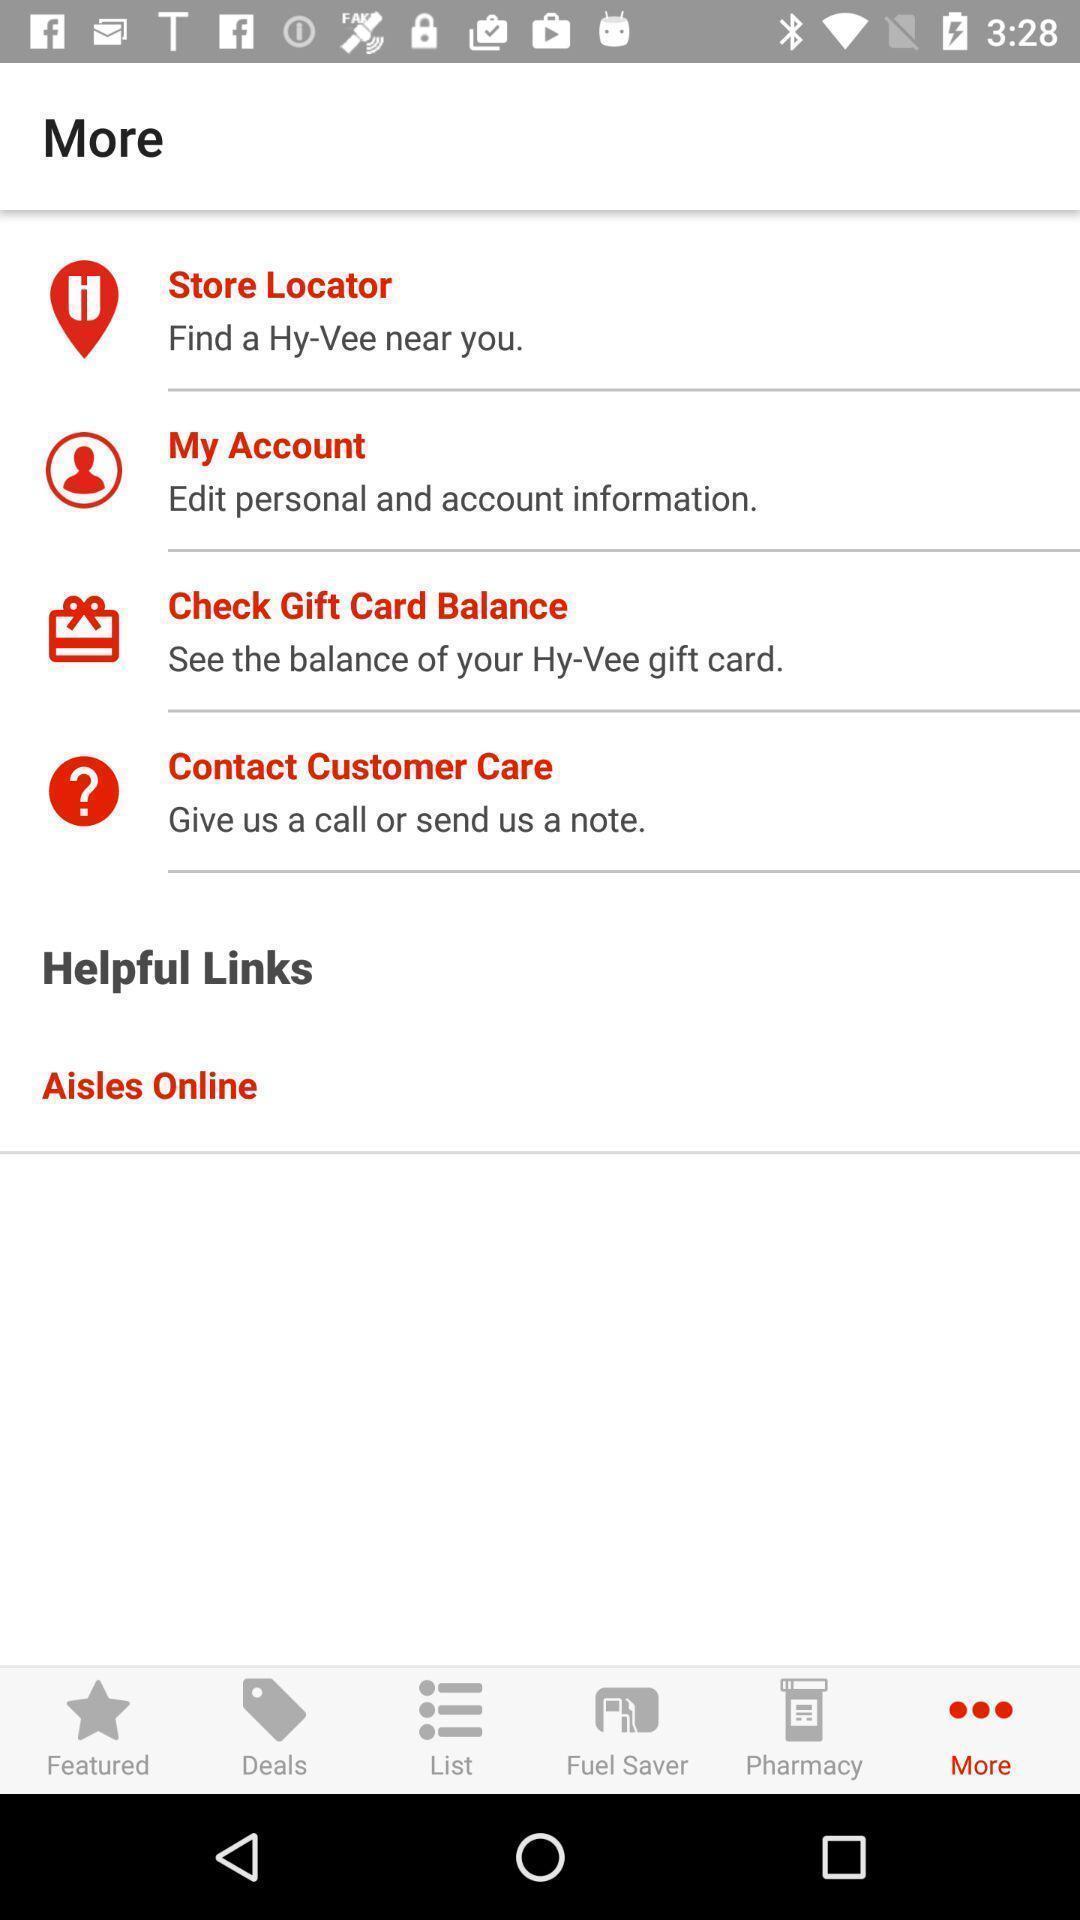Provide a textual representation of this image. Screen displaying multiple options with icons and names. 